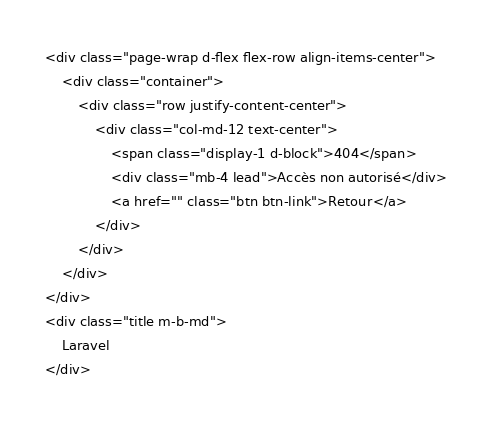Convert code to text. <code><loc_0><loc_0><loc_500><loc_500><_PHP_><div class="page-wrap d-flex flex-row align-items-center">
    <div class="container">
        <div class="row justify-content-center">
            <div class="col-md-12 text-center">
                <span class="display-1 d-block">404</span>
                <div class="mb-4 lead">Accès non autorisé</div>
                <a href="" class="btn btn-link">Retour</a>
            </div>
        </div>
    </div>
</div>
<div class="title m-b-md">
    Laravel
</div></code> 